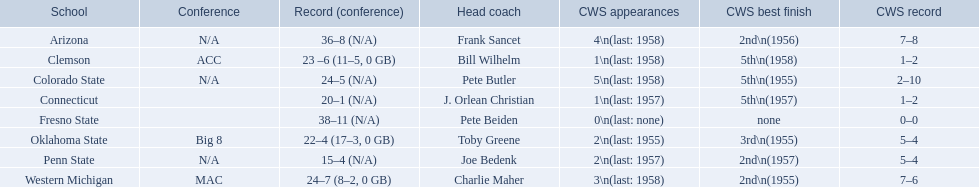What teams make up the conference? Arizona, Clemson, Colorado State, Connecticut, Fresno State, Oklahoma State, Penn State, Western Michigan. Which of these teams have a win count higher than 16? Arizona, Clemson, Colorado State, Connecticut, Fresno State, Oklahoma State, Western Michigan. Which teams have a win count lower than 16? Penn State. 